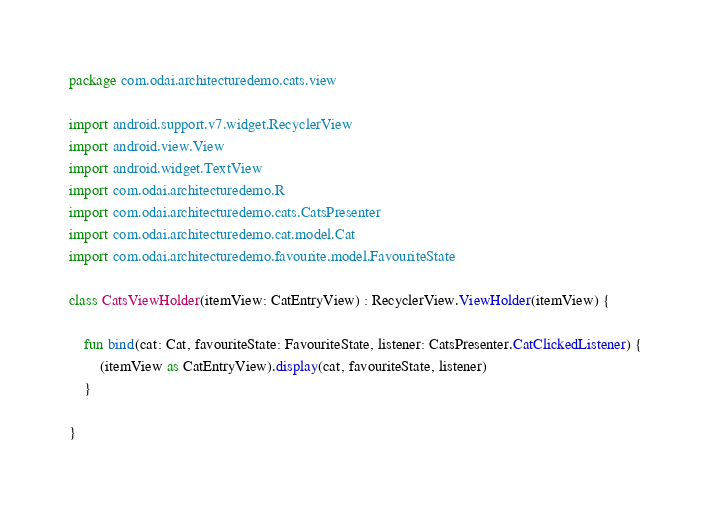Convert code to text. <code><loc_0><loc_0><loc_500><loc_500><_Kotlin_>package com.odai.architecturedemo.cats.view

import android.support.v7.widget.RecyclerView
import android.view.View
import android.widget.TextView
import com.odai.architecturedemo.R
import com.odai.architecturedemo.cats.CatsPresenter
import com.odai.architecturedemo.cat.model.Cat
import com.odai.architecturedemo.favourite.model.FavouriteState

class CatsViewHolder(itemView: CatEntryView) : RecyclerView.ViewHolder(itemView) {

    fun bind(cat: Cat, favouriteState: FavouriteState, listener: CatsPresenter.CatClickedListener) {
        (itemView as CatEntryView).display(cat, favouriteState, listener)
    }

}
</code> 